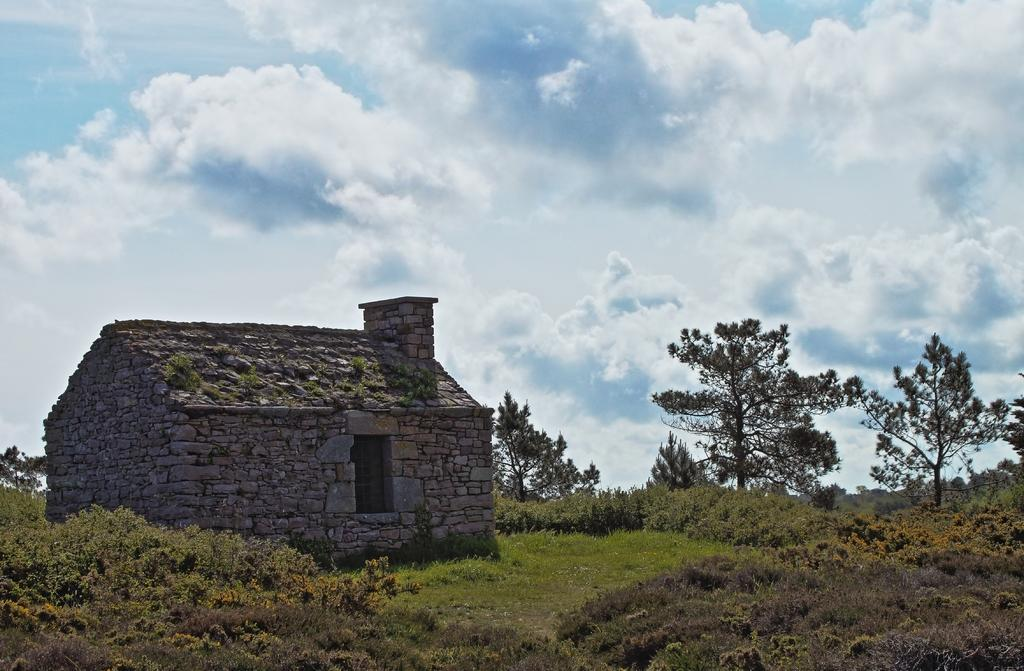What type of house is in the image? There is a pebbles house in the image. Where is the pebbles house located in the image? The pebbles house is on the left side of the image. What can be seen around the pebbles house? There is greenery around the pebbles house. What type of fuel is used to power the pebbles house in the image? There is no information about the fuel used to power the pebbles house in the image. 